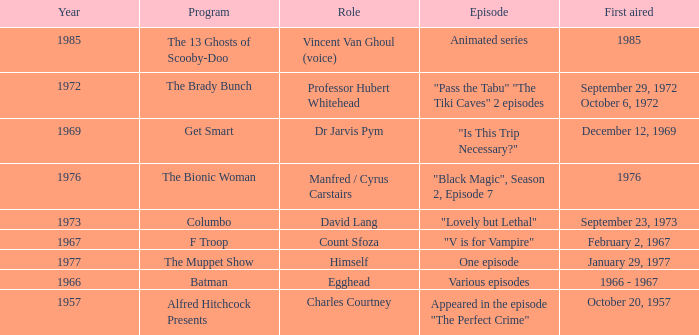What episode was first aired in 1976? "Black Magic", Season 2, Episode 7. 